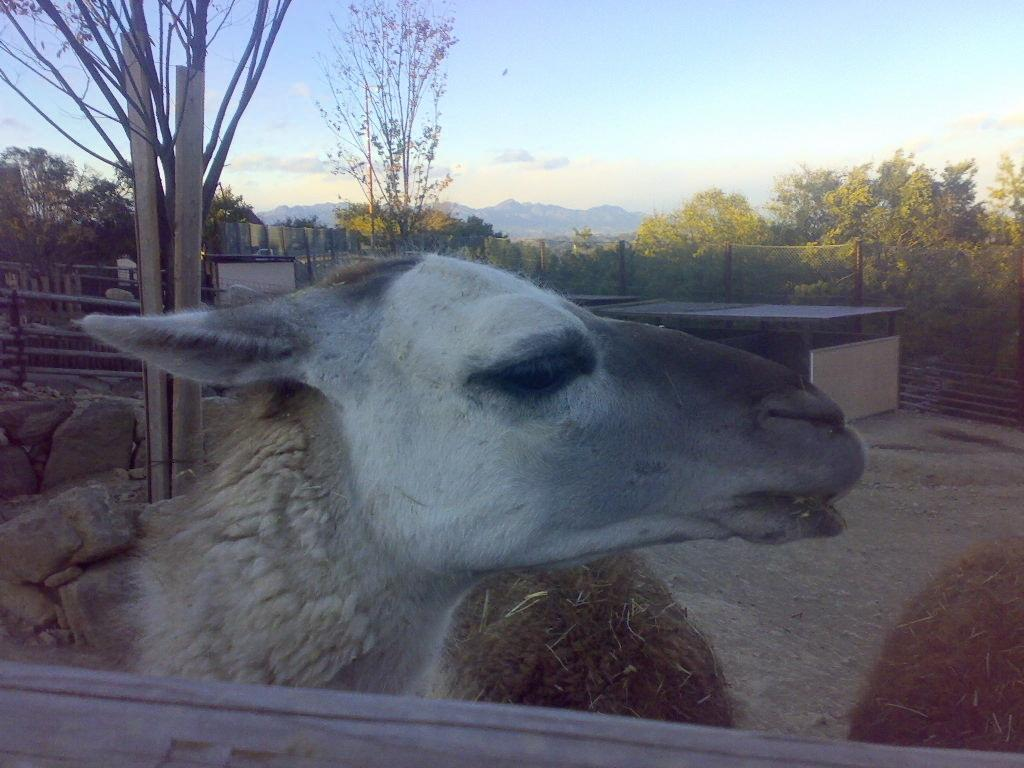What type of animal is in the image? There is an animal in the image, but the specific type cannot be determined from the provided facts. What type of vegetation is present in the image? There is grass and a tree in the image. What type of man-made structures are in the image? There is a shed and a fence in the image. What natural elements are present in the image? There are stones and trees in the image. What is visible in the background of the image? There are trees and the sky visible in the background of the image. What type of food is the animal eating in the image? There is no food present in the image, and the animal's actions are not described. What is the relation between the animal and the shed in the image? There is no information about the relationship between the animal and the shed in the image. 